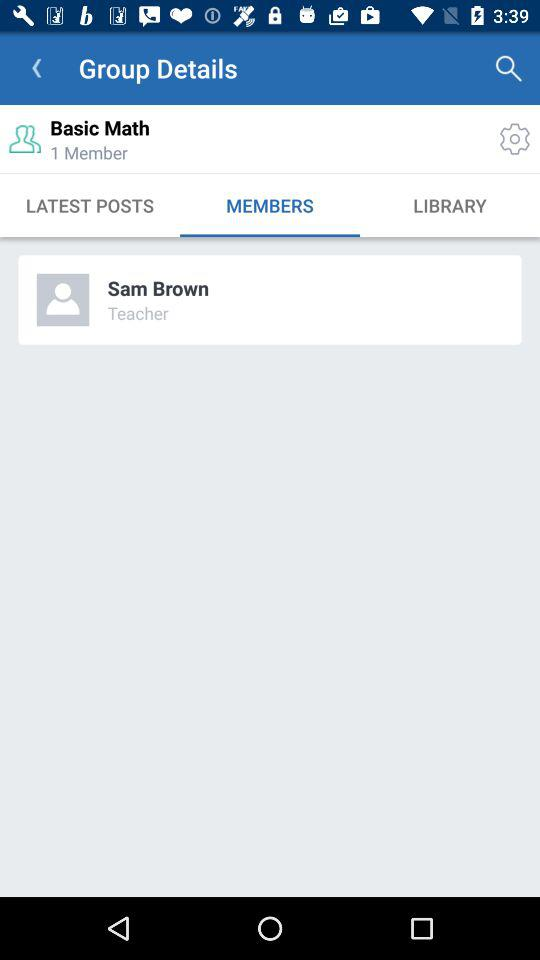How many more members does the group have than teachers?
Answer the question using a single word or phrase. 0 